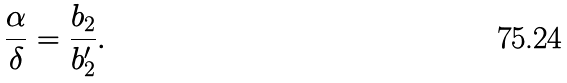Convert formula to latex. <formula><loc_0><loc_0><loc_500><loc_500>\frac { \alpha } { \delta } = \frac { b _ { 2 } } { b _ { 2 } ^ { \prime } } .</formula> 